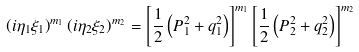<formula> <loc_0><loc_0><loc_500><loc_500>\left ( { i \eta _ { 1 } \xi _ { 1 } } \right ) ^ { m _ { 1 } } \left ( { i \eta _ { 2 } \xi _ { 2 } } \right ) ^ { m _ { 2 } } = \left [ { \frac { 1 } { 2 } \left ( { P _ { 1 } ^ { 2 } + q _ { 1 } ^ { 2 } } \right ) } \right ] ^ { m _ { 1 } } \left [ { \frac { 1 } { 2 } \left ( { P _ { 2 } ^ { 2 } + q _ { 2 } ^ { 2 } } \right ) } \right ] ^ { m _ { 2 } }</formula> 